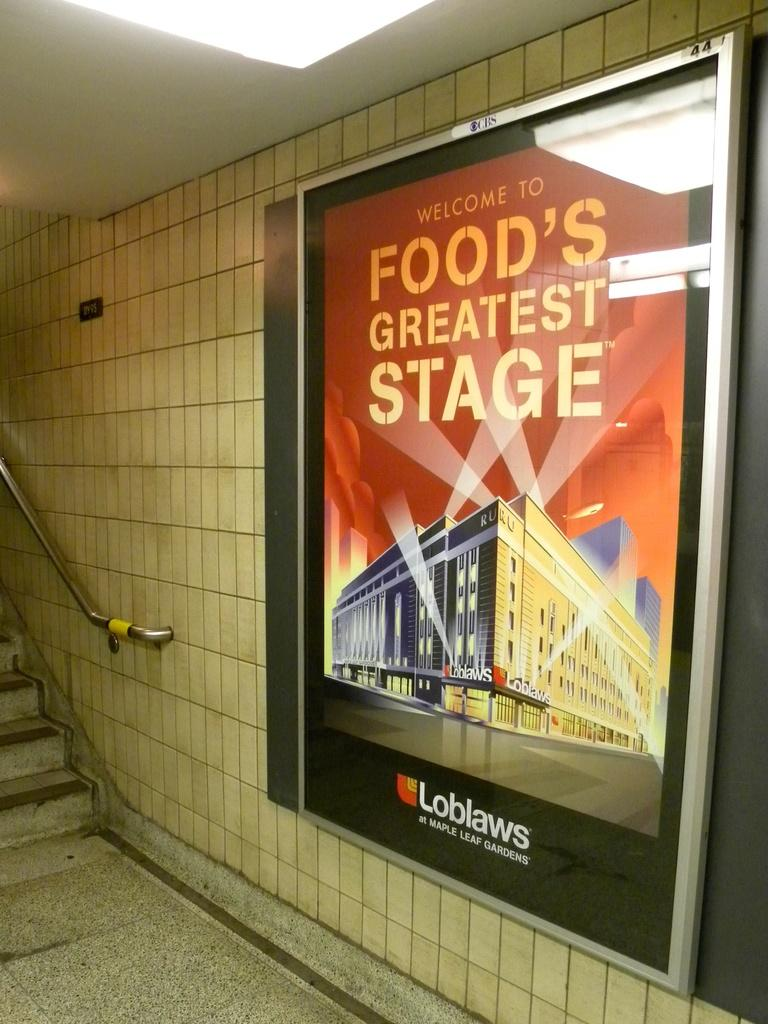<image>
Summarize the visual content of the image. A sign in a subway station that says "Welcome to Food's Greatest Stage" 